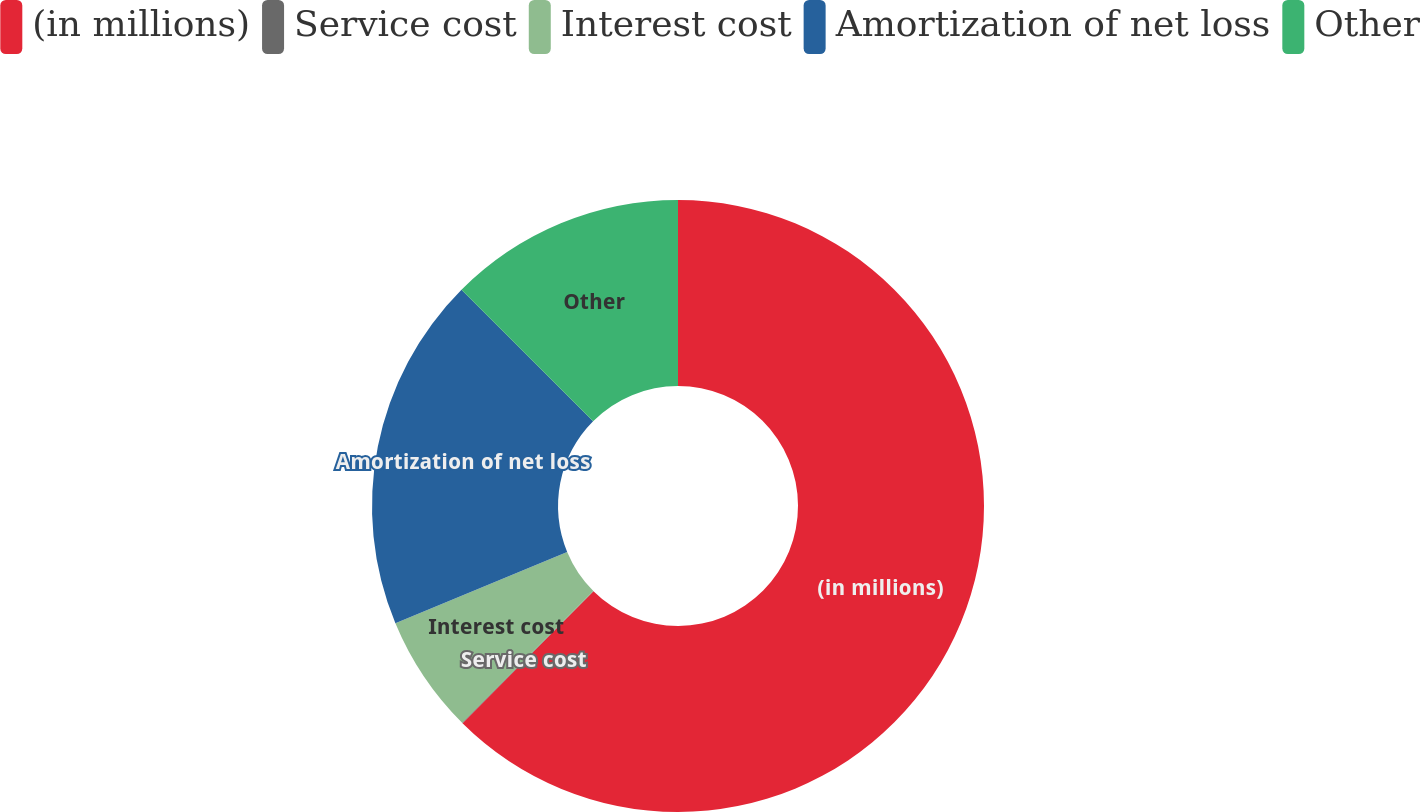Convert chart to OTSL. <chart><loc_0><loc_0><loc_500><loc_500><pie_chart><fcel>(in millions)<fcel>Service cost<fcel>Interest cost<fcel>Amortization of net loss<fcel>Other<nl><fcel>62.43%<fcel>0.03%<fcel>6.27%<fcel>18.75%<fcel>12.51%<nl></chart> 